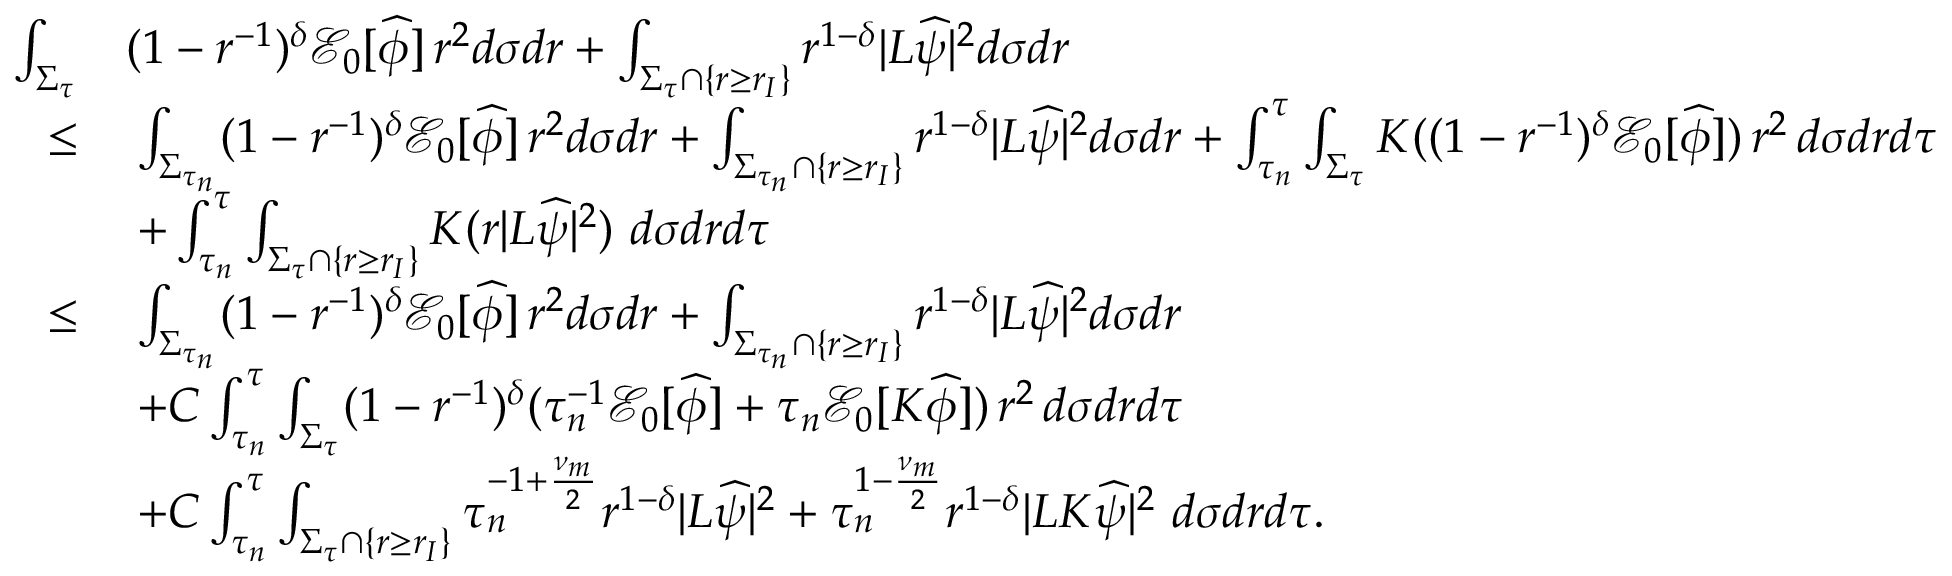<formula> <loc_0><loc_0><loc_500><loc_500>\begin{array} { r l } { \int _ { \Sigma _ { \tau } } } & { ( 1 - r ^ { - 1 } ) ^ { \delta } \mathcal { E } _ { 0 } [ \widehat { \phi } ] \, r ^ { 2 } d \sigma d r + \int _ { \Sigma _ { \tau } \cap \{ r \geq r _ { I } \} } r ^ { 1 - \delta } | L \widehat { \psi } | ^ { 2 } d \sigma d r } \\ { \leq } & { \, \int _ { \Sigma _ { \tau _ { n } } } ( 1 - r ^ { - 1 } ) ^ { \delta } \mathcal { E } _ { 0 } [ \widehat { \phi } ] \, r ^ { 2 } d \sigma d r + \int _ { \Sigma _ { \tau _ { n } } \cap \{ r \geq r _ { I } \} } r ^ { 1 - \delta } | L \widehat { \psi } | ^ { 2 } d \sigma d r + \int _ { \tau _ { n } } ^ { \tau } \int _ { \Sigma _ { \tau } } K ( ( 1 - r ^ { - 1 } ) ^ { \delta } \mathcal { E } _ { 0 } [ \widehat { \phi } ] ) \, r ^ { 2 } \, d \sigma d r d \tau } \\ & { \, + \int _ { \tau _ { n } } ^ { \tau } \int _ { \Sigma _ { \tau } \cap \{ r \geq r _ { I } \} } K ( r | L \widehat { \psi } | ^ { 2 } ) \, d \sigma d r d \tau } \\ { \leq } & { \, \int _ { \Sigma _ { \tau _ { n } } } ( 1 - r ^ { - 1 } ) ^ { \delta } \mathcal { E } _ { 0 } [ \widehat { \phi } ] \, r ^ { 2 } d \sigma d r + \int _ { \Sigma _ { \tau _ { n } } \cap \{ r \geq r _ { I } \} } r ^ { 1 - \delta } | L \widehat { \psi } | ^ { 2 } d \sigma d r } \\ & { \, + C \int _ { \tau _ { n } } ^ { \tau } \int _ { \Sigma _ { \tau } } ( 1 - r ^ { - 1 } ) ^ { \delta } ( \tau _ { n } ^ { - 1 } \mathcal { E } _ { 0 } [ \widehat { \phi } ] + \tau _ { n } \mathcal { E } _ { 0 } [ K \widehat { \phi } ] ) \, r ^ { 2 } \, d \sigma d r d \tau } \\ & { \, + C \int _ { \tau _ { n } } ^ { \tau } \int _ { \Sigma _ { \tau } \cap \{ r \geq r _ { I } \} } \tau _ { n } ^ { - 1 + \frac { \nu _ { m } } { 2 } } r ^ { 1 - \delta } | L \widehat { \psi } | ^ { 2 } + \tau _ { n } ^ { 1 - \frac { \nu _ { m } } { 2 } } r ^ { 1 - \delta } | L K \widehat { \psi } | ^ { 2 } \, d \sigma d r d \tau . } \end{array}</formula> 